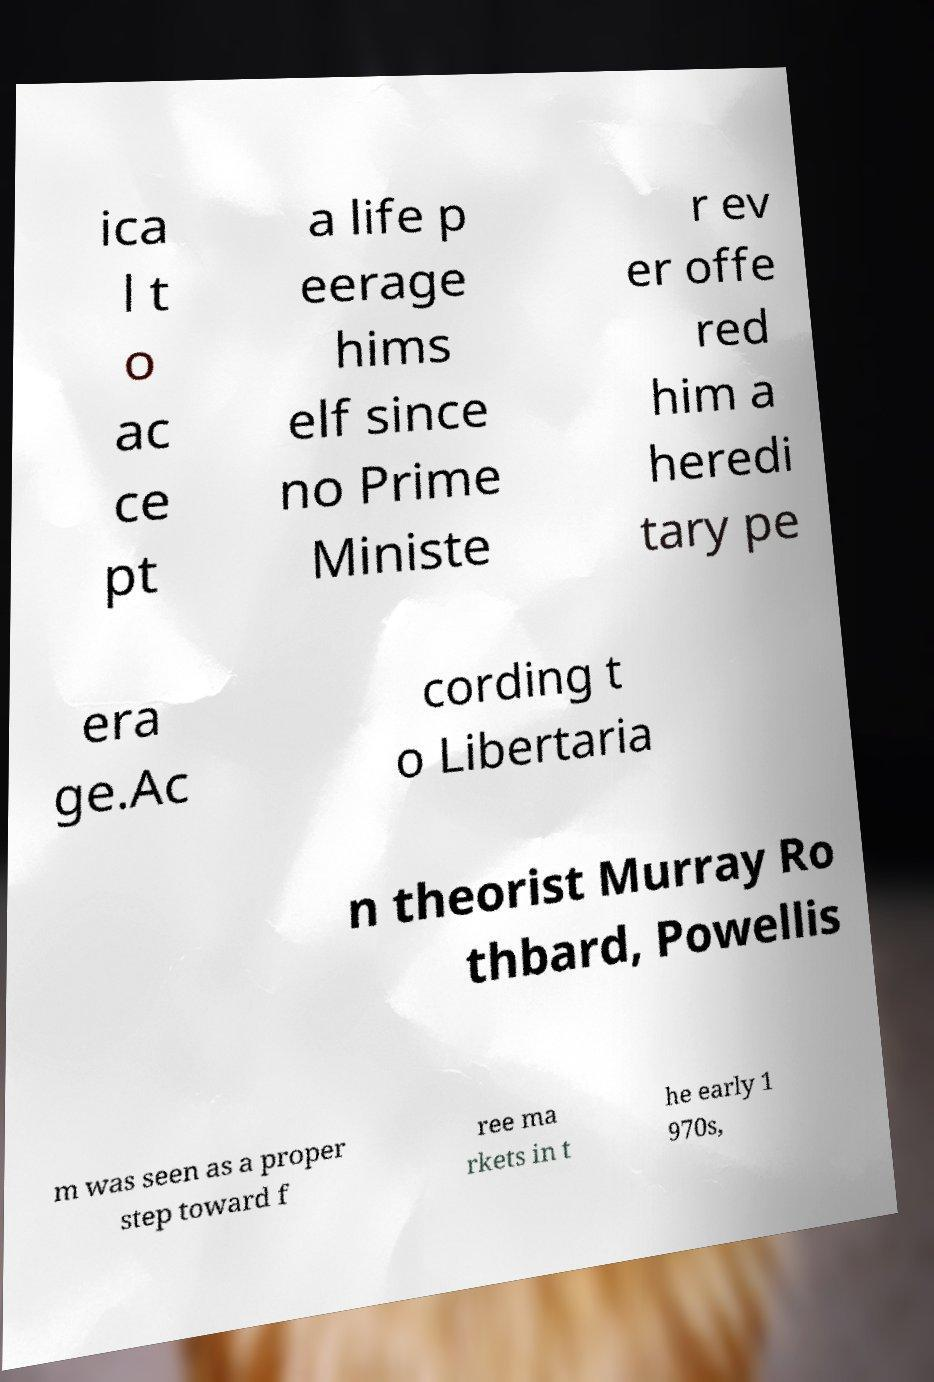Could you extract and type out the text from this image? ica l t o ac ce pt a life p eerage hims elf since no Prime Ministe r ev er offe red him a heredi tary pe era ge.Ac cording t o Libertaria n theorist Murray Ro thbard, Powellis m was seen as a proper step toward f ree ma rkets in t he early 1 970s, 